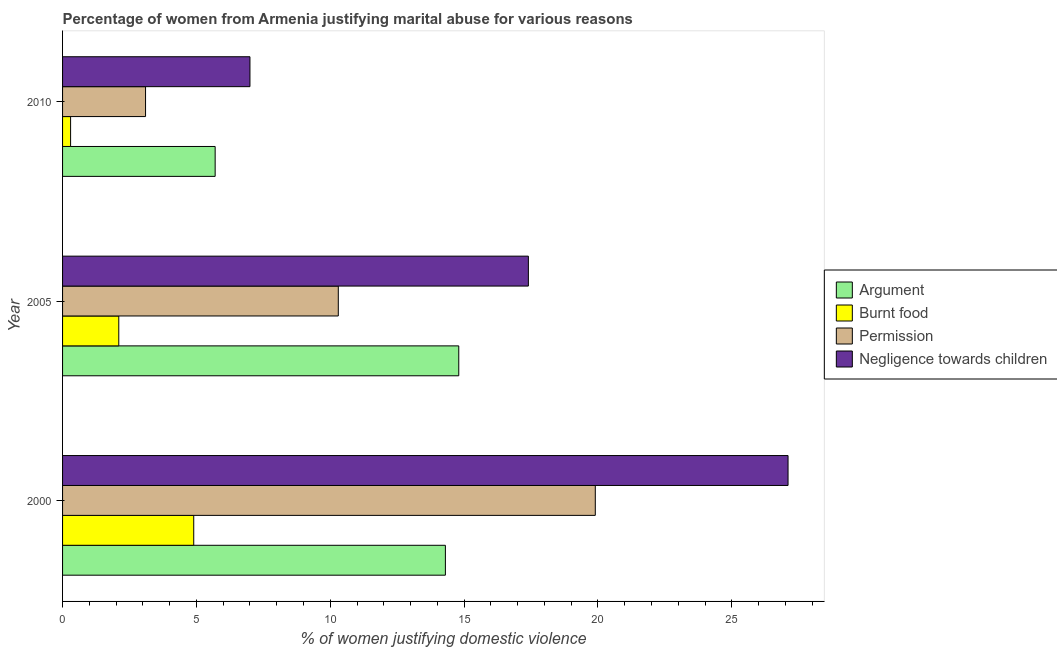How many different coloured bars are there?
Give a very brief answer. 4. How many groups of bars are there?
Provide a succinct answer. 3. Are the number of bars per tick equal to the number of legend labels?
Provide a succinct answer. Yes. Are the number of bars on each tick of the Y-axis equal?
Your answer should be compact. Yes. How many bars are there on the 2nd tick from the bottom?
Your response must be concise. 4. In how many cases, is the number of bars for a given year not equal to the number of legend labels?
Keep it short and to the point. 0. What is the percentage of women justifying abuse for burning food in 2000?
Provide a short and direct response. 4.9. Across all years, what is the maximum percentage of women justifying abuse for burning food?
Offer a terse response. 4.9. Across all years, what is the minimum percentage of women justifying abuse for showing negligence towards children?
Offer a terse response. 7. In which year was the percentage of women justifying abuse for burning food minimum?
Provide a short and direct response. 2010. What is the total percentage of women justifying abuse for going without permission in the graph?
Give a very brief answer. 33.3. What is the difference between the percentage of women justifying abuse for burning food in 2000 and that in 2010?
Ensure brevity in your answer.  4.6. What is the difference between the percentage of women justifying abuse for showing negligence towards children in 2000 and the percentage of women justifying abuse for burning food in 2005?
Offer a very short reply. 25. What is the average percentage of women justifying abuse for showing negligence towards children per year?
Your answer should be very brief. 17.17. In how many years, is the percentage of women justifying abuse in the case of an argument greater than 5 %?
Provide a succinct answer. 3. What is the ratio of the percentage of women justifying abuse in the case of an argument in 2000 to that in 2010?
Your answer should be compact. 2.51. Is the percentage of women justifying abuse for showing negligence towards children in 2000 less than that in 2010?
Offer a very short reply. No. Is the difference between the percentage of women justifying abuse in the case of an argument in 2000 and 2005 greater than the difference between the percentage of women justifying abuse for going without permission in 2000 and 2005?
Provide a short and direct response. No. Is it the case that in every year, the sum of the percentage of women justifying abuse for burning food and percentage of women justifying abuse for going without permission is greater than the sum of percentage of women justifying abuse in the case of an argument and percentage of women justifying abuse for showing negligence towards children?
Your response must be concise. No. What does the 2nd bar from the top in 2010 represents?
Provide a short and direct response. Permission. What does the 3rd bar from the bottom in 2010 represents?
Give a very brief answer. Permission. Are all the bars in the graph horizontal?
Offer a very short reply. Yes. Are the values on the major ticks of X-axis written in scientific E-notation?
Provide a short and direct response. No. Does the graph contain any zero values?
Ensure brevity in your answer.  No. How many legend labels are there?
Offer a terse response. 4. What is the title of the graph?
Keep it short and to the point. Percentage of women from Armenia justifying marital abuse for various reasons. Does "Services" appear as one of the legend labels in the graph?
Keep it short and to the point. No. What is the label or title of the X-axis?
Ensure brevity in your answer.  % of women justifying domestic violence. What is the % of women justifying domestic violence of Argument in 2000?
Provide a short and direct response. 14.3. What is the % of women justifying domestic violence in Permission in 2000?
Keep it short and to the point. 19.9. What is the % of women justifying domestic violence in Negligence towards children in 2000?
Offer a terse response. 27.1. What is the % of women justifying domestic violence of Burnt food in 2005?
Your response must be concise. 2.1. What is the % of women justifying domestic violence of Permission in 2005?
Offer a very short reply. 10.3. What is the % of women justifying domestic violence of Negligence towards children in 2005?
Keep it short and to the point. 17.4. What is the % of women justifying domestic violence in Burnt food in 2010?
Your answer should be compact. 0.3. What is the % of women justifying domestic violence of Permission in 2010?
Keep it short and to the point. 3.1. Across all years, what is the maximum % of women justifying domestic violence of Negligence towards children?
Keep it short and to the point. 27.1. Across all years, what is the minimum % of women justifying domestic violence of Burnt food?
Provide a succinct answer. 0.3. Across all years, what is the minimum % of women justifying domestic violence of Permission?
Make the answer very short. 3.1. Across all years, what is the minimum % of women justifying domestic violence in Negligence towards children?
Your answer should be compact. 7. What is the total % of women justifying domestic violence in Argument in the graph?
Give a very brief answer. 34.8. What is the total % of women justifying domestic violence of Burnt food in the graph?
Give a very brief answer. 7.3. What is the total % of women justifying domestic violence of Permission in the graph?
Offer a very short reply. 33.3. What is the total % of women justifying domestic violence of Negligence towards children in the graph?
Keep it short and to the point. 51.5. What is the difference between the % of women justifying domestic violence of Argument in 2000 and that in 2005?
Give a very brief answer. -0.5. What is the difference between the % of women justifying domestic violence of Burnt food in 2000 and that in 2005?
Offer a terse response. 2.8. What is the difference between the % of women justifying domestic violence of Permission in 2000 and that in 2005?
Ensure brevity in your answer.  9.6. What is the difference between the % of women justifying domestic violence in Negligence towards children in 2000 and that in 2010?
Your answer should be compact. 20.1. What is the difference between the % of women justifying domestic violence in Argument in 2005 and that in 2010?
Keep it short and to the point. 9.1. What is the difference between the % of women justifying domestic violence of Permission in 2005 and that in 2010?
Ensure brevity in your answer.  7.2. What is the difference between the % of women justifying domestic violence in Argument in 2000 and the % of women justifying domestic violence in Burnt food in 2005?
Give a very brief answer. 12.2. What is the difference between the % of women justifying domestic violence in Burnt food in 2000 and the % of women justifying domestic violence in Negligence towards children in 2005?
Your answer should be very brief. -12.5. What is the difference between the % of women justifying domestic violence of Permission in 2000 and the % of women justifying domestic violence of Negligence towards children in 2005?
Provide a succinct answer. 2.5. What is the difference between the % of women justifying domestic violence of Argument in 2000 and the % of women justifying domestic violence of Permission in 2010?
Make the answer very short. 11.2. What is the difference between the % of women justifying domestic violence of Burnt food in 2000 and the % of women justifying domestic violence of Permission in 2010?
Offer a terse response. 1.8. What is the difference between the % of women justifying domestic violence of Burnt food in 2000 and the % of women justifying domestic violence of Negligence towards children in 2010?
Your answer should be very brief. -2.1. What is the difference between the % of women justifying domestic violence of Permission in 2000 and the % of women justifying domestic violence of Negligence towards children in 2010?
Make the answer very short. 12.9. What is the difference between the % of women justifying domestic violence in Argument in 2005 and the % of women justifying domestic violence in Permission in 2010?
Ensure brevity in your answer.  11.7. What is the difference between the % of women justifying domestic violence of Argument in 2005 and the % of women justifying domestic violence of Negligence towards children in 2010?
Your answer should be very brief. 7.8. What is the difference between the % of women justifying domestic violence of Burnt food in 2005 and the % of women justifying domestic violence of Negligence towards children in 2010?
Your answer should be compact. -4.9. What is the difference between the % of women justifying domestic violence of Permission in 2005 and the % of women justifying domestic violence of Negligence towards children in 2010?
Ensure brevity in your answer.  3.3. What is the average % of women justifying domestic violence of Argument per year?
Your response must be concise. 11.6. What is the average % of women justifying domestic violence in Burnt food per year?
Provide a succinct answer. 2.43. What is the average % of women justifying domestic violence of Permission per year?
Give a very brief answer. 11.1. What is the average % of women justifying domestic violence in Negligence towards children per year?
Give a very brief answer. 17.17. In the year 2000, what is the difference between the % of women justifying domestic violence in Argument and % of women justifying domestic violence in Permission?
Provide a succinct answer. -5.6. In the year 2000, what is the difference between the % of women justifying domestic violence of Burnt food and % of women justifying domestic violence of Permission?
Your answer should be compact. -15. In the year 2000, what is the difference between the % of women justifying domestic violence of Burnt food and % of women justifying domestic violence of Negligence towards children?
Your answer should be compact. -22.2. In the year 2005, what is the difference between the % of women justifying domestic violence of Argument and % of women justifying domestic violence of Permission?
Your answer should be compact. 4.5. In the year 2005, what is the difference between the % of women justifying domestic violence in Argument and % of women justifying domestic violence in Negligence towards children?
Provide a short and direct response. -2.6. In the year 2005, what is the difference between the % of women justifying domestic violence in Burnt food and % of women justifying domestic violence in Negligence towards children?
Give a very brief answer. -15.3. In the year 2005, what is the difference between the % of women justifying domestic violence of Permission and % of women justifying domestic violence of Negligence towards children?
Keep it short and to the point. -7.1. In the year 2010, what is the difference between the % of women justifying domestic violence in Argument and % of women justifying domestic violence in Burnt food?
Provide a short and direct response. 5.4. In the year 2010, what is the difference between the % of women justifying domestic violence of Burnt food and % of women justifying domestic violence of Permission?
Offer a terse response. -2.8. In the year 2010, what is the difference between the % of women justifying domestic violence of Burnt food and % of women justifying domestic violence of Negligence towards children?
Your answer should be very brief. -6.7. In the year 2010, what is the difference between the % of women justifying domestic violence in Permission and % of women justifying domestic violence in Negligence towards children?
Provide a succinct answer. -3.9. What is the ratio of the % of women justifying domestic violence of Argument in 2000 to that in 2005?
Give a very brief answer. 0.97. What is the ratio of the % of women justifying domestic violence in Burnt food in 2000 to that in 2005?
Offer a very short reply. 2.33. What is the ratio of the % of women justifying domestic violence in Permission in 2000 to that in 2005?
Ensure brevity in your answer.  1.93. What is the ratio of the % of women justifying domestic violence of Negligence towards children in 2000 to that in 2005?
Provide a succinct answer. 1.56. What is the ratio of the % of women justifying domestic violence of Argument in 2000 to that in 2010?
Offer a very short reply. 2.51. What is the ratio of the % of women justifying domestic violence in Burnt food in 2000 to that in 2010?
Make the answer very short. 16.33. What is the ratio of the % of women justifying domestic violence of Permission in 2000 to that in 2010?
Provide a succinct answer. 6.42. What is the ratio of the % of women justifying domestic violence in Negligence towards children in 2000 to that in 2010?
Keep it short and to the point. 3.87. What is the ratio of the % of women justifying domestic violence of Argument in 2005 to that in 2010?
Provide a short and direct response. 2.6. What is the ratio of the % of women justifying domestic violence of Burnt food in 2005 to that in 2010?
Your answer should be compact. 7. What is the ratio of the % of women justifying domestic violence of Permission in 2005 to that in 2010?
Keep it short and to the point. 3.32. What is the ratio of the % of women justifying domestic violence in Negligence towards children in 2005 to that in 2010?
Keep it short and to the point. 2.49. What is the difference between the highest and the lowest % of women justifying domestic violence of Argument?
Provide a succinct answer. 9.1. What is the difference between the highest and the lowest % of women justifying domestic violence in Permission?
Keep it short and to the point. 16.8. What is the difference between the highest and the lowest % of women justifying domestic violence in Negligence towards children?
Keep it short and to the point. 20.1. 